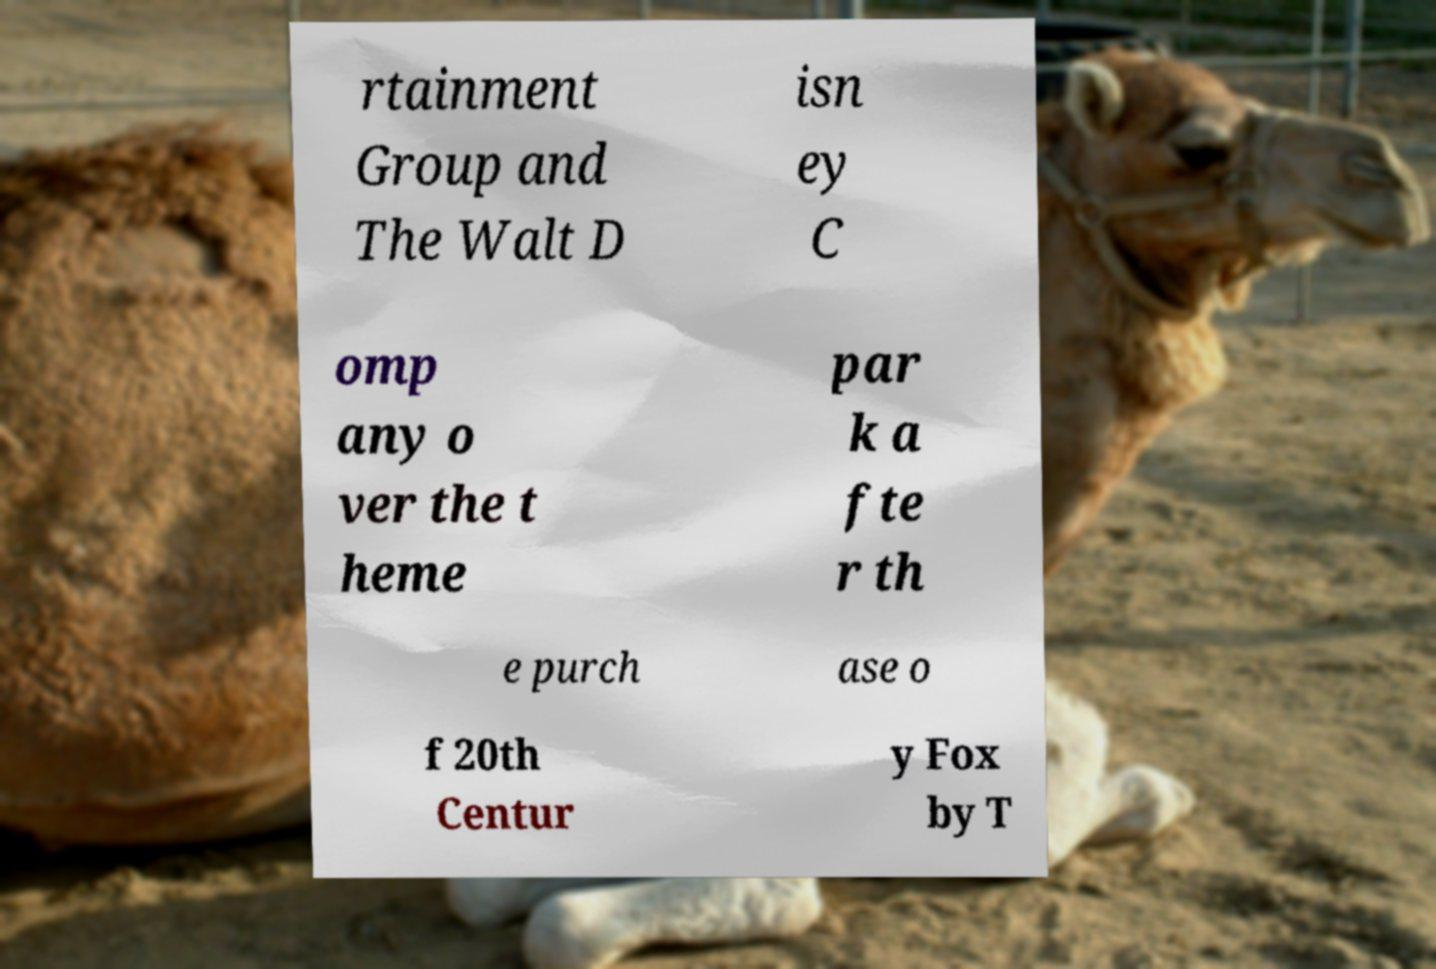Please identify and transcribe the text found in this image. rtainment Group and The Walt D isn ey C omp any o ver the t heme par k a fte r th e purch ase o f 20th Centur y Fox by T 